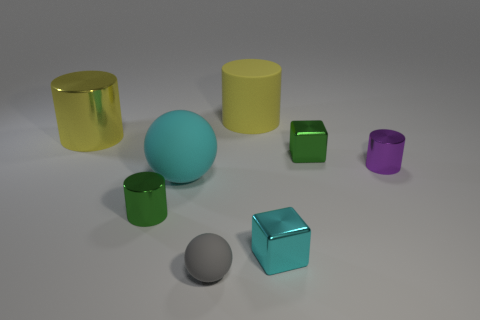What number of things are either cylinders that are in front of the cyan matte ball or big yellow things on the left side of the tiny gray ball? 2 